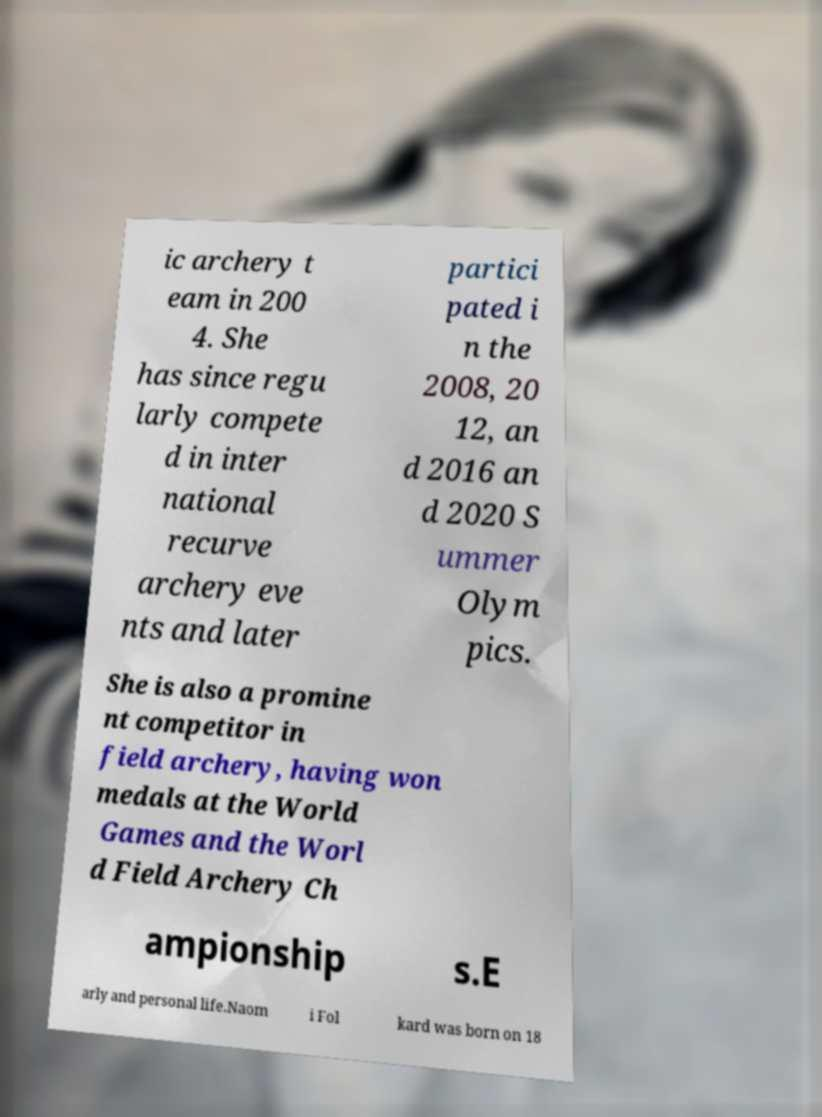For documentation purposes, I need the text within this image transcribed. Could you provide that? ic archery t eam in 200 4. She has since regu larly compete d in inter national recurve archery eve nts and later partici pated i n the 2008, 20 12, an d 2016 an d 2020 S ummer Olym pics. She is also a promine nt competitor in field archery, having won medals at the World Games and the Worl d Field Archery Ch ampionship s.E arly and personal life.Naom i Fol kard was born on 18 